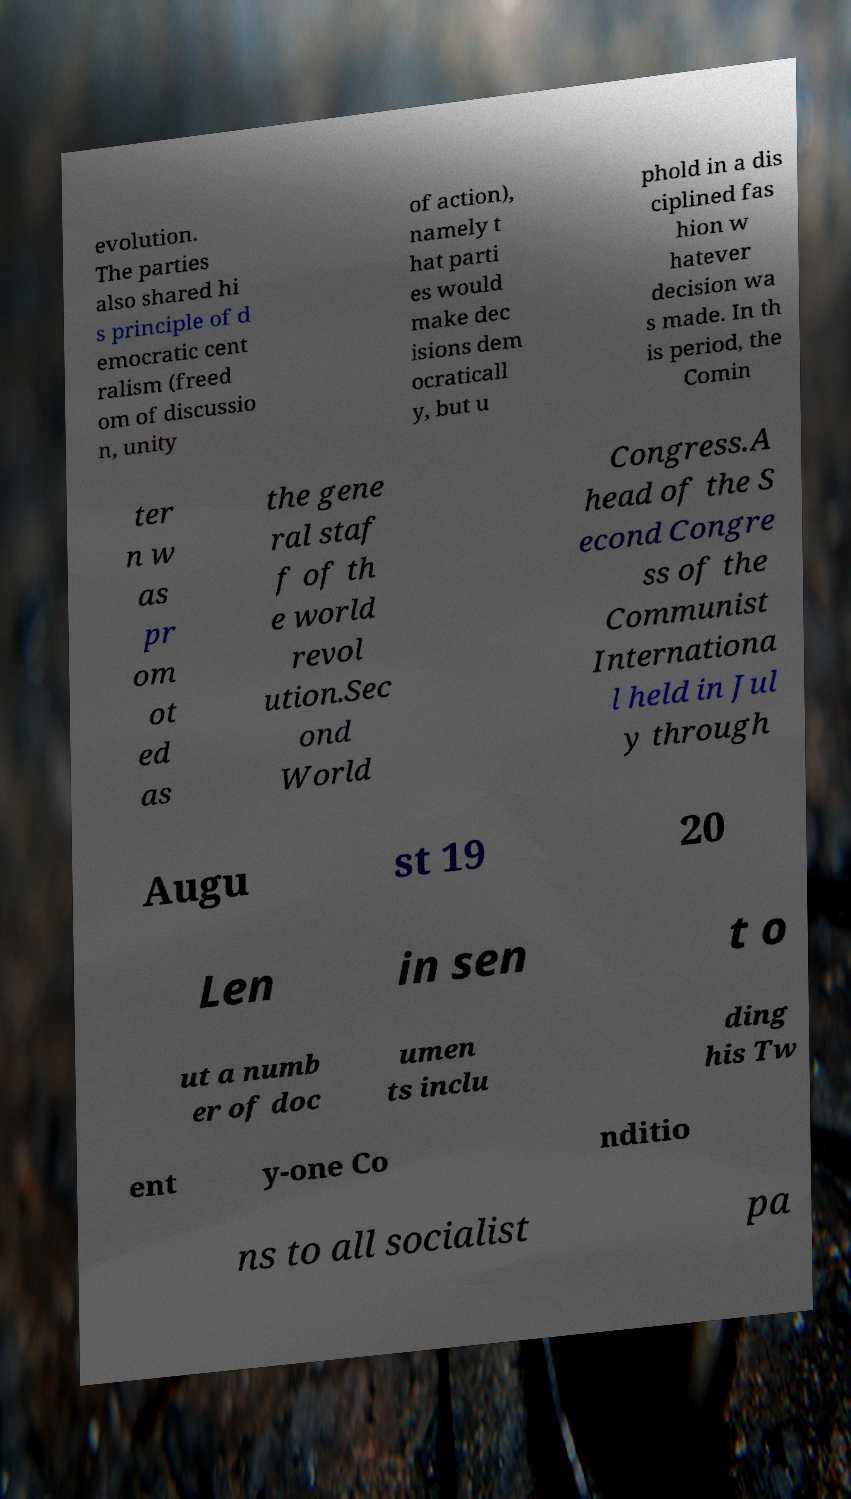I need the written content from this picture converted into text. Can you do that? evolution. The parties also shared hi s principle of d emocratic cent ralism (freed om of discussio n, unity of action), namely t hat parti es would make dec isions dem ocraticall y, but u phold in a dis ciplined fas hion w hatever decision wa s made. In th is period, the Comin ter n w as pr om ot ed as the gene ral staf f of th e world revol ution.Sec ond World Congress.A head of the S econd Congre ss of the Communist Internationa l held in Jul y through Augu st 19 20 Len in sen t o ut a numb er of doc umen ts inclu ding his Tw ent y-one Co nditio ns to all socialist pa 